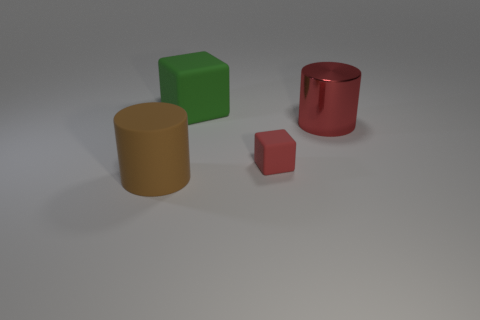Add 4 rubber balls. How many objects exist? 8 Subtract all red cylinders. How many cylinders are left? 1 Subtract all red balls. How many red cylinders are left? 1 Subtract all green blocks. Subtract all large yellow blocks. How many objects are left? 3 Add 1 large green matte blocks. How many large green matte blocks are left? 2 Add 3 big red cylinders. How many big red cylinders exist? 4 Subtract 0 yellow cylinders. How many objects are left? 4 Subtract 2 cylinders. How many cylinders are left? 0 Subtract all gray cylinders. Subtract all green balls. How many cylinders are left? 2 